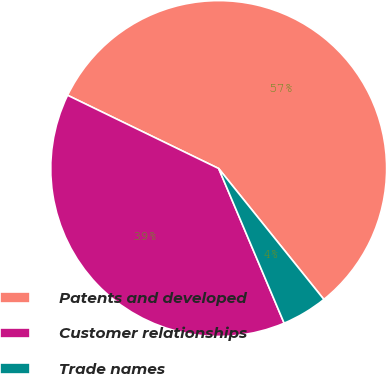<chart> <loc_0><loc_0><loc_500><loc_500><pie_chart><fcel>Patents and developed<fcel>Customer relationships<fcel>Trade names<nl><fcel>57.04%<fcel>38.56%<fcel>4.4%<nl></chart> 